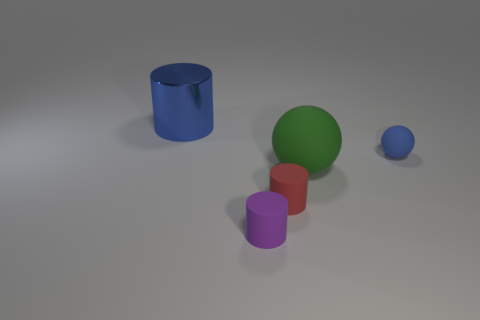Is the small blue matte thing the same shape as the small red thing? no 